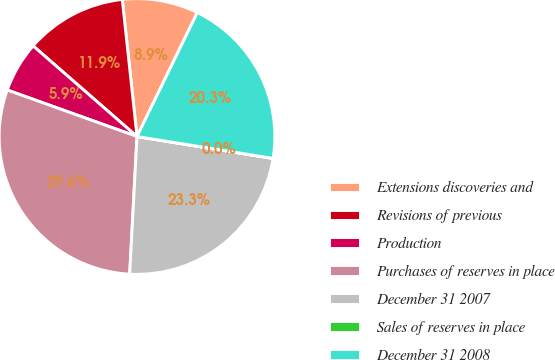Convert chart to OTSL. <chart><loc_0><loc_0><loc_500><loc_500><pie_chart><fcel>Extensions discoveries and<fcel>Revisions of previous<fcel>Production<fcel>Purchases of reserves in place<fcel>December 31 2007<fcel>Sales of reserves in place<fcel>December 31 2008<nl><fcel>8.91%<fcel>11.88%<fcel>5.94%<fcel>29.63%<fcel>23.3%<fcel>0.01%<fcel>20.33%<nl></chart> 